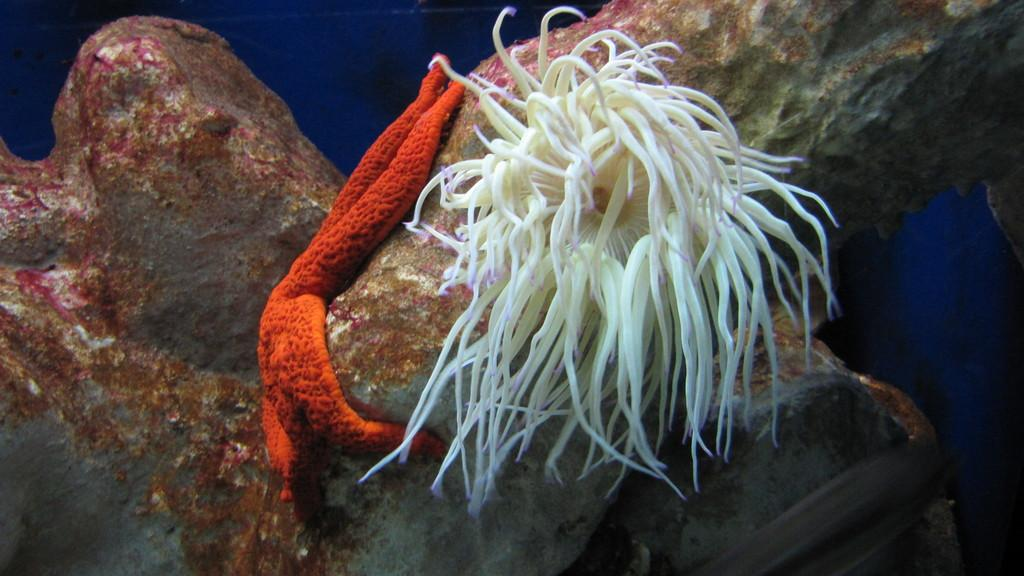What type of marine animal is in the image? There is a starfish in the image. Can you describe the setting of the image? There is a sea creature on a rock in the water in the image. How many ducks are sitting on the dock in the image? There are no ducks or docks present in the image. 